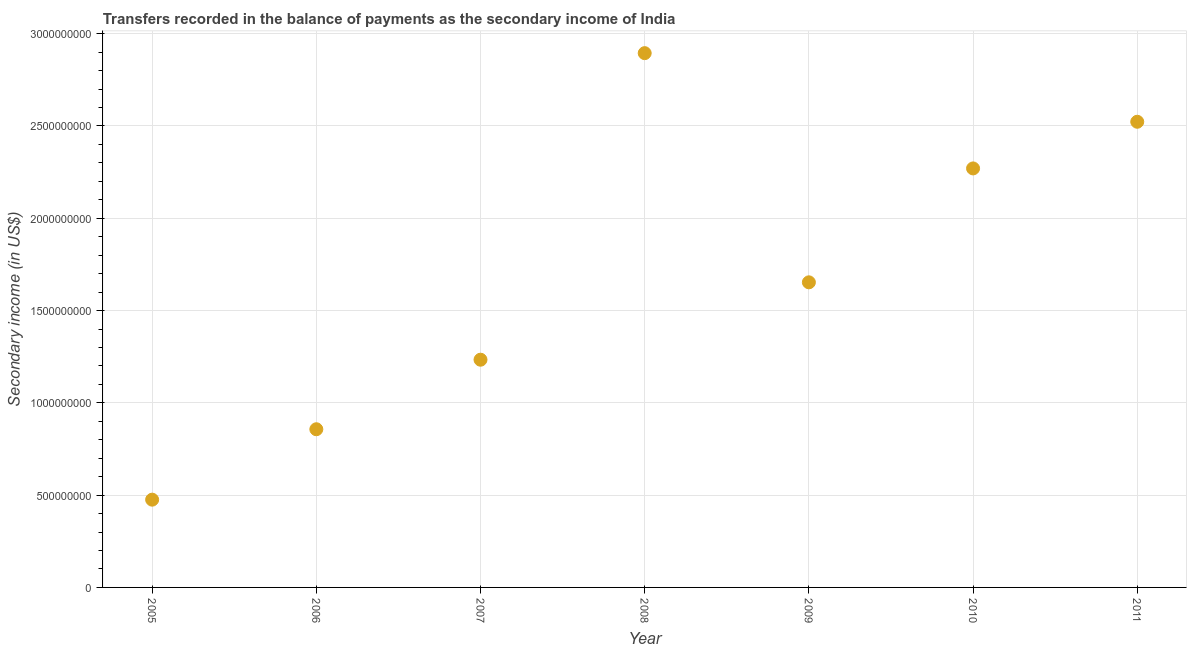What is the amount of secondary income in 2010?
Ensure brevity in your answer.  2.27e+09. Across all years, what is the maximum amount of secondary income?
Give a very brief answer. 2.89e+09. Across all years, what is the minimum amount of secondary income?
Make the answer very short. 4.76e+08. What is the sum of the amount of secondary income?
Give a very brief answer. 1.19e+1. What is the difference between the amount of secondary income in 2006 and 2010?
Ensure brevity in your answer.  -1.41e+09. What is the average amount of secondary income per year?
Make the answer very short. 1.70e+09. What is the median amount of secondary income?
Your answer should be compact. 1.65e+09. What is the ratio of the amount of secondary income in 2007 to that in 2010?
Ensure brevity in your answer.  0.54. Is the difference between the amount of secondary income in 2005 and 2007 greater than the difference between any two years?
Your answer should be compact. No. What is the difference between the highest and the second highest amount of secondary income?
Ensure brevity in your answer.  3.72e+08. What is the difference between the highest and the lowest amount of secondary income?
Give a very brief answer. 2.42e+09. Does the amount of secondary income monotonically increase over the years?
Offer a terse response. No. What is the difference between two consecutive major ticks on the Y-axis?
Give a very brief answer. 5.00e+08. Are the values on the major ticks of Y-axis written in scientific E-notation?
Ensure brevity in your answer.  No. What is the title of the graph?
Your answer should be very brief. Transfers recorded in the balance of payments as the secondary income of India. What is the label or title of the X-axis?
Offer a very short reply. Year. What is the label or title of the Y-axis?
Your response must be concise. Secondary income (in US$). What is the Secondary income (in US$) in 2005?
Ensure brevity in your answer.  4.76e+08. What is the Secondary income (in US$) in 2006?
Give a very brief answer. 8.57e+08. What is the Secondary income (in US$) in 2007?
Make the answer very short. 1.23e+09. What is the Secondary income (in US$) in 2008?
Provide a short and direct response. 2.89e+09. What is the Secondary income (in US$) in 2009?
Offer a terse response. 1.65e+09. What is the Secondary income (in US$) in 2010?
Provide a succinct answer. 2.27e+09. What is the Secondary income (in US$) in 2011?
Provide a succinct answer. 2.52e+09. What is the difference between the Secondary income (in US$) in 2005 and 2006?
Provide a short and direct response. -3.82e+08. What is the difference between the Secondary income (in US$) in 2005 and 2007?
Make the answer very short. -7.58e+08. What is the difference between the Secondary income (in US$) in 2005 and 2008?
Your answer should be compact. -2.42e+09. What is the difference between the Secondary income (in US$) in 2005 and 2009?
Make the answer very short. -1.18e+09. What is the difference between the Secondary income (in US$) in 2005 and 2010?
Keep it short and to the point. -1.79e+09. What is the difference between the Secondary income (in US$) in 2005 and 2011?
Ensure brevity in your answer.  -2.05e+09. What is the difference between the Secondary income (in US$) in 2006 and 2007?
Your response must be concise. -3.77e+08. What is the difference between the Secondary income (in US$) in 2006 and 2008?
Your answer should be compact. -2.04e+09. What is the difference between the Secondary income (in US$) in 2006 and 2009?
Your answer should be very brief. -7.96e+08. What is the difference between the Secondary income (in US$) in 2006 and 2010?
Your answer should be very brief. -1.41e+09. What is the difference between the Secondary income (in US$) in 2006 and 2011?
Make the answer very short. -1.67e+09. What is the difference between the Secondary income (in US$) in 2007 and 2008?
Make the answer very short. -1.66e+09. What is the difference between the Secondary income (in US$) in 2007 and 2009?
Your answer should be compact. -4.19e+08. What is the difference between the Secondary income (in US$) in 2007 and 2010?
Your response must be concise. -1.04e+09. What is the difference between the Secondary income (in US$) in 2007 and 2011?
Your answer should be very brief. -1.29e+09. What is the difference between the Secondary income (in US$) in 2008 and 2009?
Provide a short and direct response. 1.24e+09. What is the difference between the Secondary income (in US$) in 2008 and 2010?
Ensure brevity in your answer.  6.25e+08. What is the difference between the Secondary income (in US$) in 2008 and 2011?
Offer a very short reply. 3.72e+08. What is the difference between the Secondary income (in US$) in 2009 and 2010?
Provide a succinct answer. -6.17e+08. What is the difference between the Secondary income (in US$) in 2009 and 2011?
Offer a very short reply. -8.70e+08. What is the difference between the Secondary income (in US$) in 2010 and 2011?
Your answer should be compact. -2.53e+08. What is the ratio of the Secondary income (in US$) in 2005 to that in 2006?
Offer a very short reply. 0.56. What is the ratio of the Secondary income (in US$) in 2005 to that in 2007?
Offer a very short reply. 0.39. What is the ratio of the Secondary income (in US$) in 2005 to that in 2008?
Offer a very short reply. 0.16. What is the ratio of the Secondary income (in US$) in 2005 to that in 2009?
Offer a very short reply. 0.29. What is the ratio of the Secondary income (in US$) in 2005 to that in 2010?
Give a very brief answer. 0.21. What is the ratio of the Secondary income (in US$) in 2005 to that in 2011?
Give a very brief answer. 0.19. What is the ratio of the Secondary income (in US$) in 2006 to that in 2007?
Your response must be concise. 0.69. What is the ratio of the Secondary income (in US$) in 2006 to that in 2008?
Your response must be concise. 0.3. What is the ratio of the Secondary income (in US$) in 2006 to that in 2009?
Give a very brief answer. 0.52. What is the ratio of the Secondary income (in US$) in 2006 to that in 2010?
Your response must be concise. 0.38. What is the ratio of the Secondary income (in US$) in 2006 to that in 2011?
Your answer should be very brief. 0.34. What is the ratio of the Secondary income (in US$) in 2007 to that in 2008?
Make the answer very short. 0.43. What is the ratio of the Secondary income (in US$) in 2007 to that in 2009?
Your response must be concise. 0.75. What is the ratio of the Secondary income (in US$) in 2007 to that in 2010?
Provide a succinct answer. 0.54. What is the ratio of the Secondary income (in US$) in 2007 to that in 2011?
Ensure brevity in your answer.  0.49. What is the ratio of the Secondary income (in US$) in 2008 to that in 2009?
Your response must be concise. 1.75. What is the ratio of the Secondary income (in US$) in 2008 to that in 2010?
Make the answer very short. 1.27. What is the ratio of the Secondary income (in US$) in 2008 to that in 2011?
Provide a short and direct response. 1.15. What is the ratio of the Secondary income (in US$) in 2009 to that in 2010?
Keep it short and to the point. 0.73. What is the ratio of the Secondary income (in US$) in 2009 to that in 2011?
Your answer should be very brief. 0.66. What is the ratio of the Secondary income (in US$) in 2010 to that in 2011?
Ensure brevity in your answer.  0.9. 